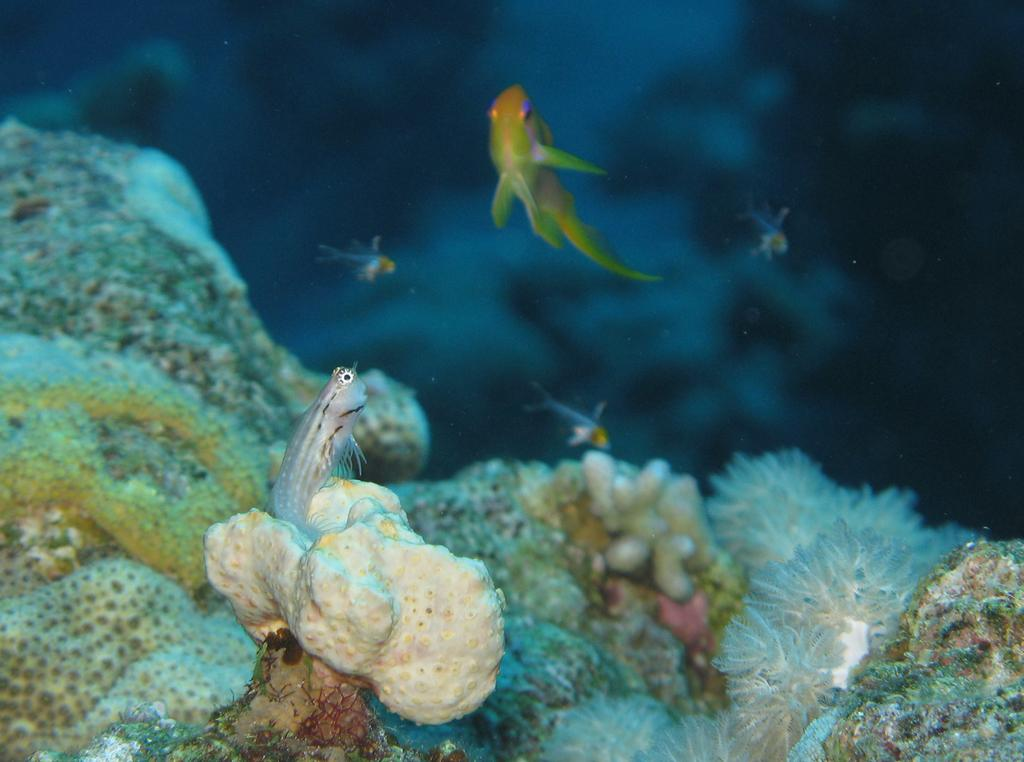What is the setting of the image? The image is taken underwater. What types of living organisms can be seen in the image? There are animals and other species in the image. What type of plastic can be seen in the image? There is no plastic present in the image. 